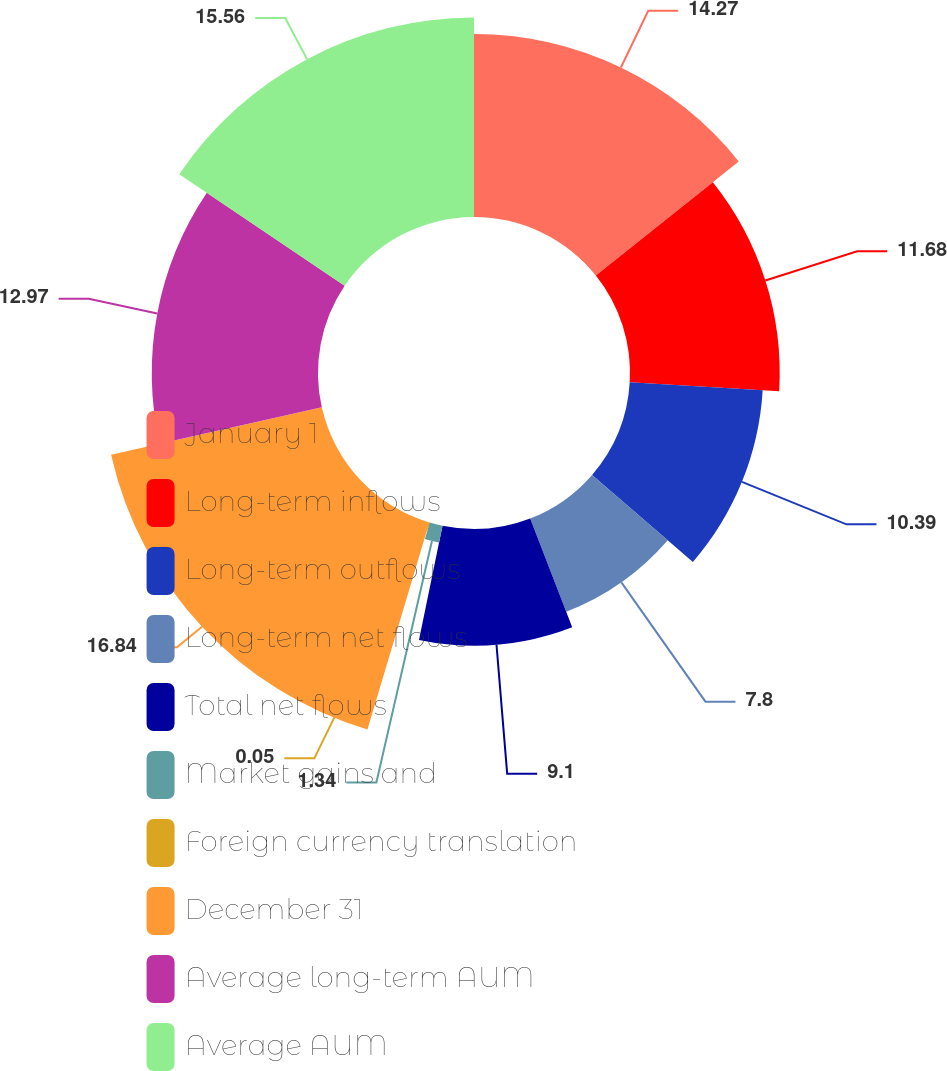Convert chart to OTSL. <chart><loc_0><loc_0><loc_500><loc_500><pie_chart><fcel>January 1<fcel>Long-term inflows<fcel>Long-term outflows<fcel>Long-term net flows<fcel>Total net flows<fcel>Market gains and<fcel>Foreign currency translation<fcel>December 31<fcel>Average long-term AUM<fcel>Average AUM<nl><fcel>14.27%<fcel>11.68%<fcel>10.39%<fcel>7.8%<fcel>9.1%<fcel>1.34%<fcel>0.05%<fcel>16.85%<fcel>12.97%<fcel>15.56%<nl></chart> 